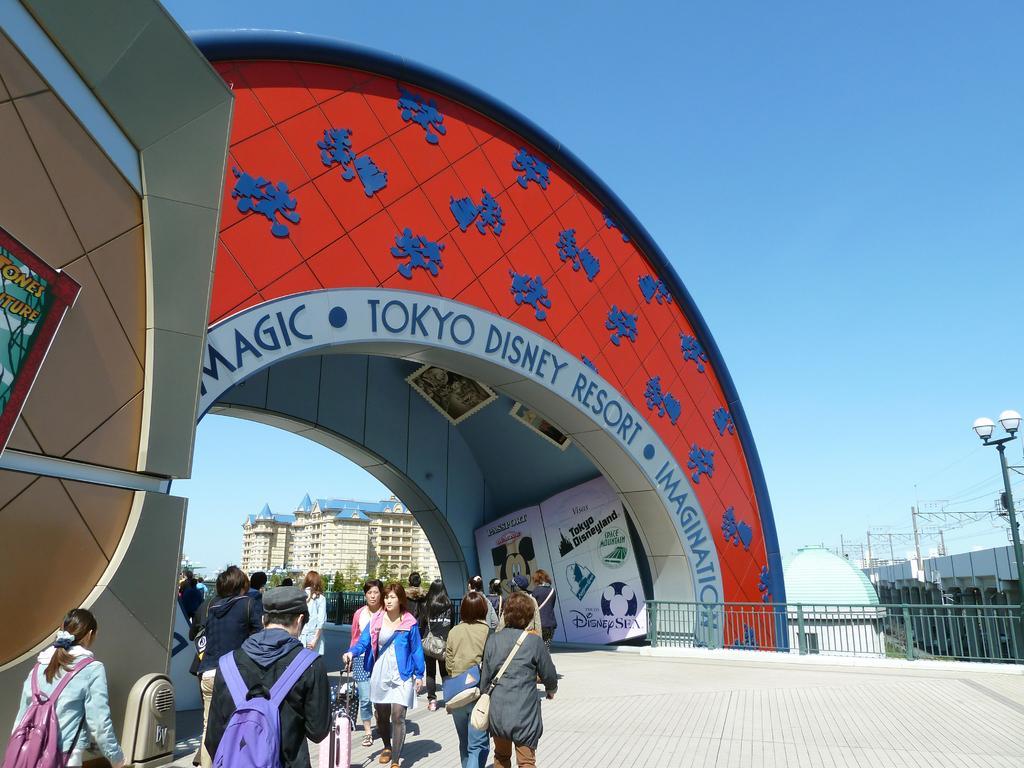Please provide a concise description of this image. This image is taken outdoors. At the top of the image there is the sky. At the bottom of the image there is a floor. In the background there are a few buildings. On the right side of the image there is a pole with a street light. There are a few poles and wires. There is a bridge. There is a railing. There is a cabin. On the left side of the image a few people are walking on the floor. There is a wall. There is a board with a text on it. In the middle of the image there is an architecture and there is a text on it. There are a few boards with a text and a few images on them. 